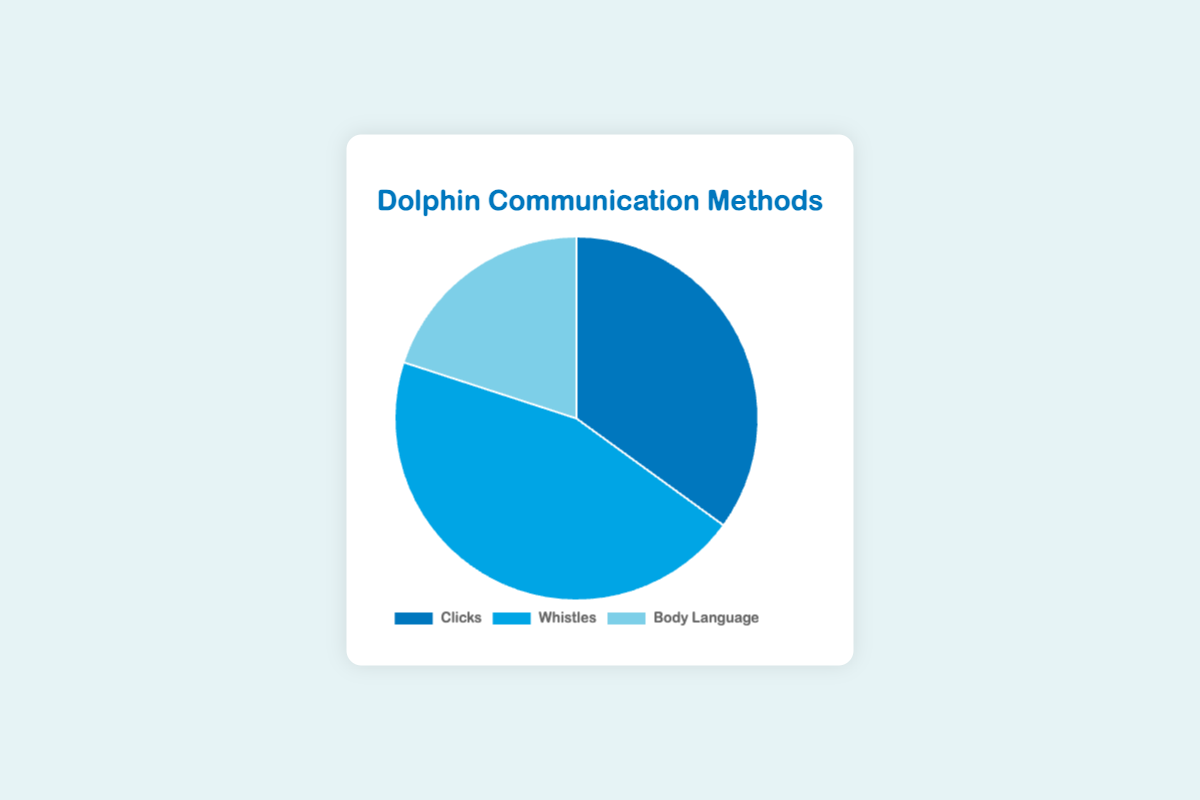What is the most commonly used communication method by dolphins? Observing the pie chart, the largest segment represents Whistles with 45%. Therefore, whistles are the most commonly used communication method.
Answer: Whistles What percentage of communication methods are non-verbal? Non-verbal communication methods involve 'Body Language'. According to the chart, Body Language accounts for 20% of the communication methods.
Answer: 20% How much more frequent are Whistles compared to Body Language? Whistles are at 45% and Body Language at 20%. The difference is 45% - 20%, which equals 25%.
Answer: 25% Which method uses the least amount of communication by dolphins? The smallest segment in the pie chart is for Body Language, representing 20%.
Answer: Body Language Are Clicks and Body Language together half of dolphin communication? Clicks are 35% and Body Language is 20%. Together, they account for 35% + 20% = 55%, which is greater than half of dolphin communication.
Answer: No How many times more frequent are Whistles compared to Clicks? Whistles are at 45% and Clicks at 35%. The ratio is 45% / 35% which simplifies to approximately 1.29 times more frequent.
Answer: 1.29 times If we consider only non-verbal methods, what fraction do they represent out of the total communication? Non-verbal communication is represented by Body Language, which is 20%. Out of 100%, this is 20/100 = 1/5 or one-fifth of the total communication.
Answer: 1/5 What two methods combine to represent a greater percentage than the third method alone? Whistles are 45%, Clicks are 35%, and Body Language is 20%. Both Clicks and Body Language together are 35% + 20% = 55%, which is greater than Whistles at 45%.
Answer: Clicks and Body Language If we group all methods that produce sound (Clicks and Whistles), what's their combined percentage? Clicks represent 35% and Whistles 45%. Together, their combined percentage is 35% + 45% = 80%.
Answer: 80% What is the ratio of verbal (Clicks and Whistles) to non-verbal (Body Language) communication methods? Verbal communication methods add up to 35% (Clicks) + 45% (Whistles) = 80%. Non-verbal methods are 20%. The ratio is 80% to 20% or 4:1.
Answer: 4:1 